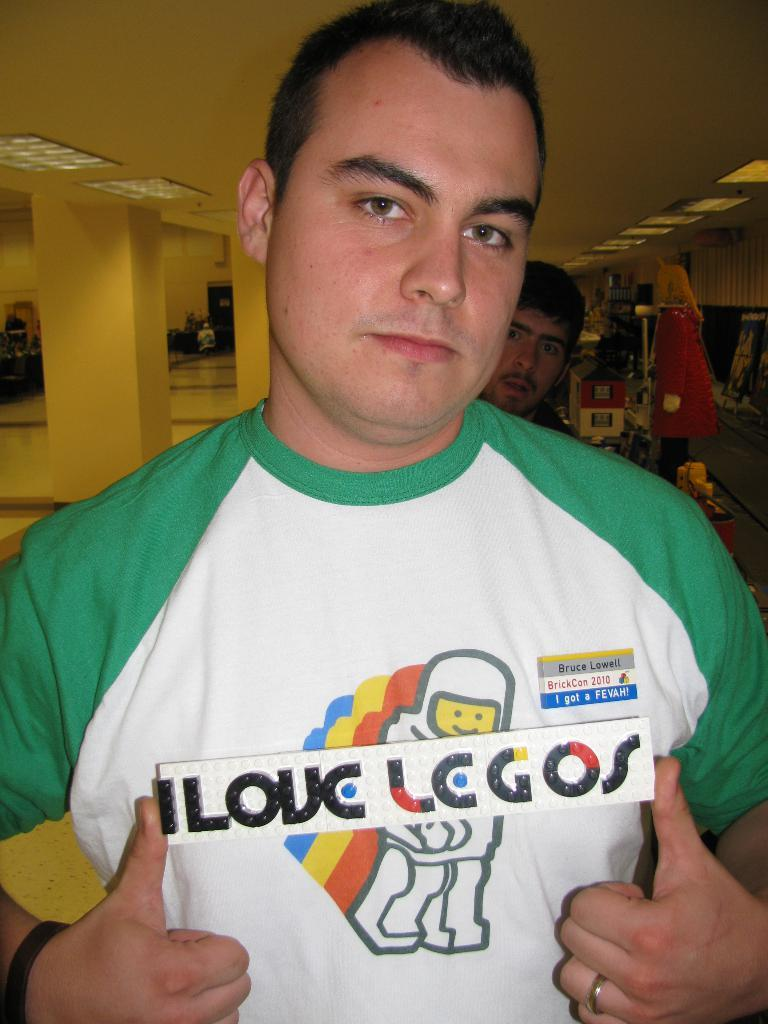<image>
Share a concise interpretation of the image provided. a man holding a sign saying I Love Legos 